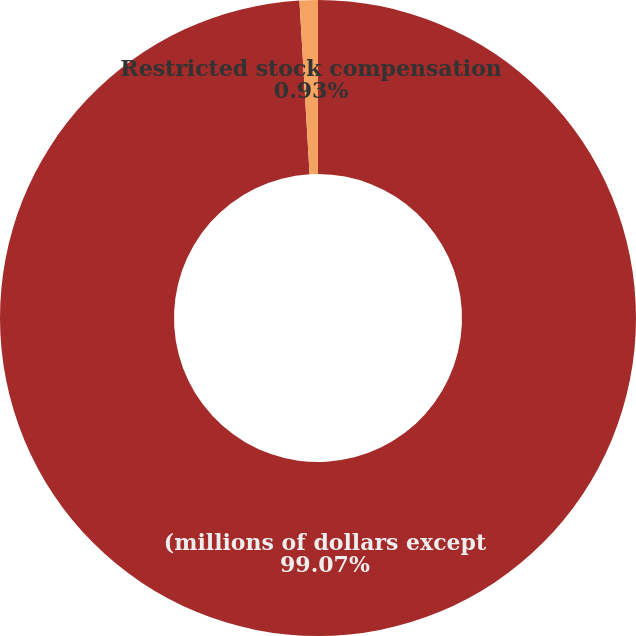Convert chart. <chart><loc_0><loc_0><loc_500><loc_500><pie_chart><fcel>(millions of dollars except<fcel>Restricted stock compensation<nl><fcel>99.07%<fcel>0.93%<nl></chart> 